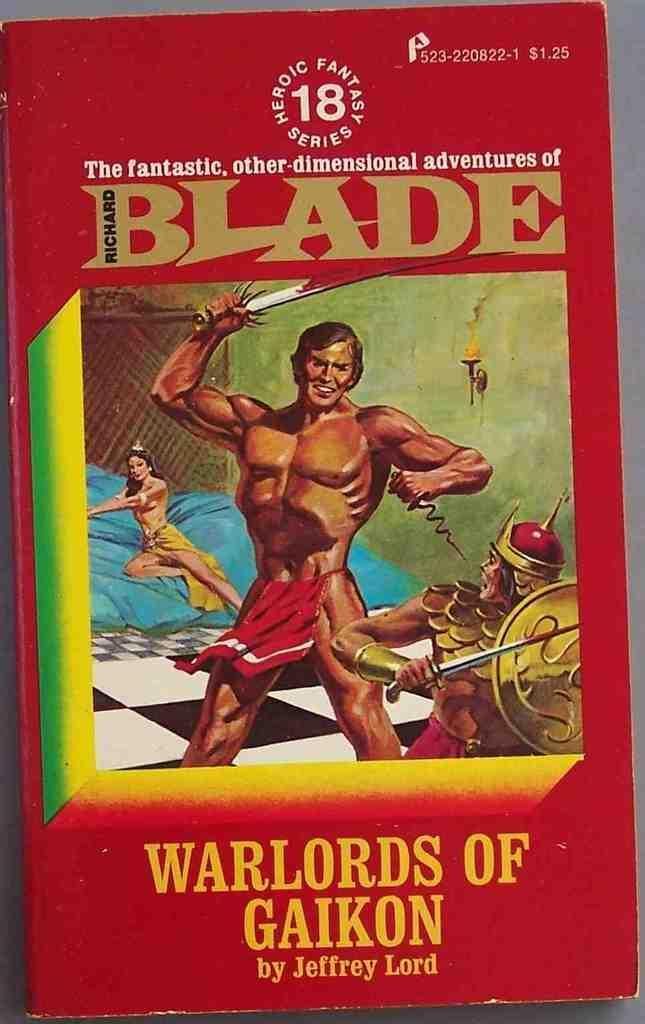Can you describe this image briefly? In this image there is a table with a book on it. The book is in red color. 